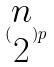<formula> <loc_0><loc_0><loc_500><loc_500>( \begin{matrix} n \\ 2 \end{matrix} ) p</formula> 